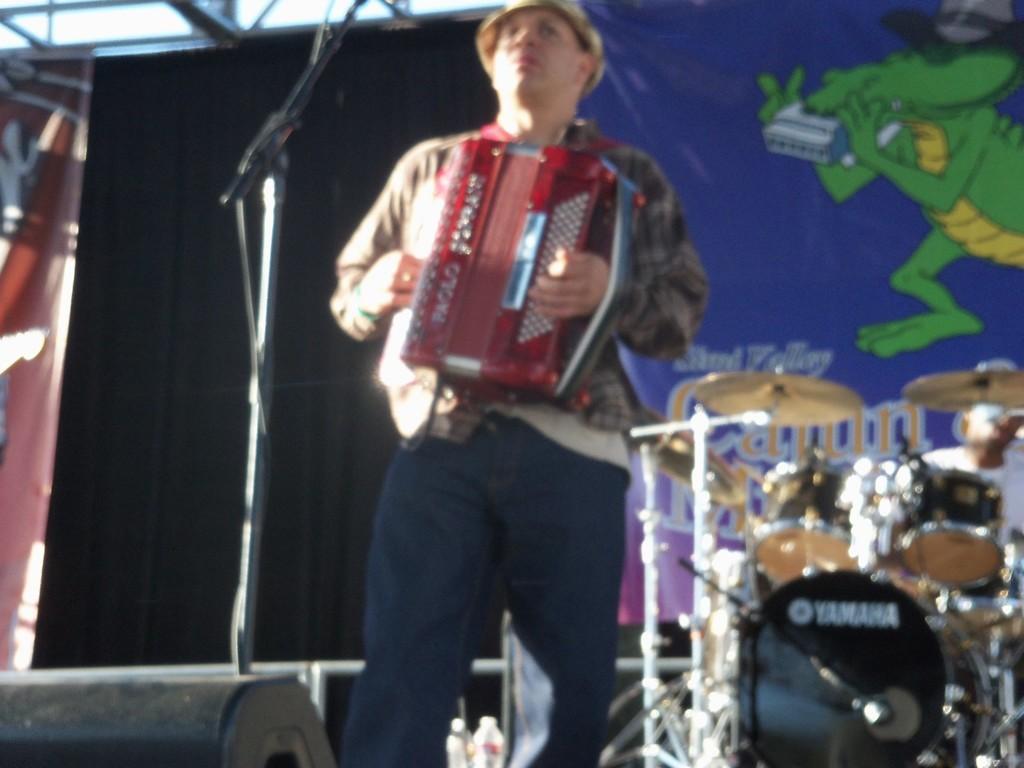Could you give a brief overview of what you see in this image? In this picture there is a person standing and playing a musical instrument in front of a mic and there are few other musical instruments and banner behind him. 